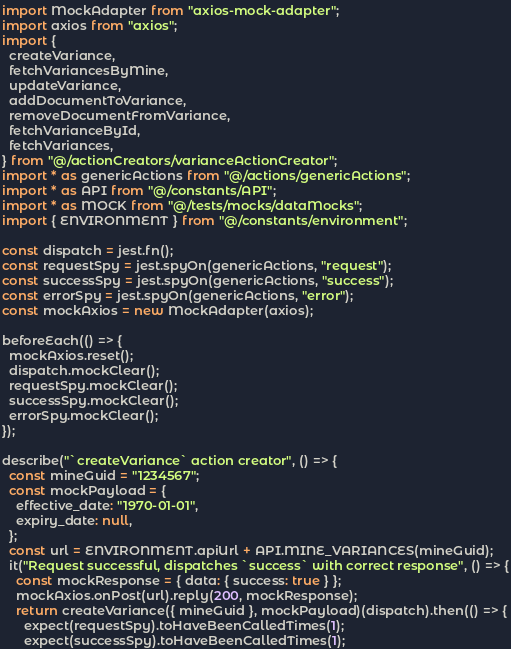<code> <loc_0><loc_0><loc_500><loc_500><_JavaScript_>import MockAdapter from "axios-mock-adapter";
import axios from "axios";
import {
  createVariance,
  fetchVariancesByMine,
  updateVariance,
  addDocumentToVariance,
  removeDocumentFromVariance,
  fetchVarianceById,
  fetchVariances,
} from "@/actionCreators/varianceActionCreator";
import * as genericActions from "@/actions/genericActions";
import * as API from "@/constants/API";
import * as MOCK from "@/tests/mocks/dataMocks";
import { ENVIRONMENT } from "@/constants/environment";

const dispatch = jest.fn();
const requestSpy = jest.spyOn(genericActions, "request");
const successSpy = jest.spyOn(genericActions, "success");
const errorSpy = jest.spyOn(genericActions, "error");
const mockAxios = new MockAdapter(axios);

beforeEach(() => {
  mockAxios.reset();
  dispatch.mockClear();
  requestSpy.mockClear();
  successSpy.mockClear();
  errorSpy.mockClear();
});

describe("`createVariance` action creator", () => {
  const mineGuid = "1234567";
  const mockPayload = {
    effective_date: "1970-01-01",
    expiry_date: null,
  };
  const url = ENVIRONMENT.apiUrl + API.MINE_VARIANCES(mineGuid);
  it("Request successful, dispatches `success` with correct response", () => {
    const mockResponse = { data: { success: true } };
    mockAxios.onPost(url).reply(200, mockResponse);
    return createVariance({ mineGuid }, mockPayload)(dispatch).then(() => {
      expect(requestSpy).toHaveBeenCalledTimes(1);
      expect(successSpy).toHaveBeenCalledTimes(1);</code> 